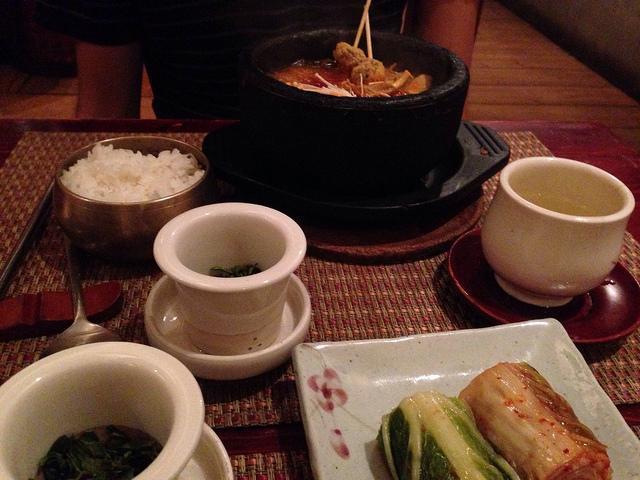How many cups are there?
Give a very brief answer. 2. How many bowls can you see?
Give a very brief answer. 6. 